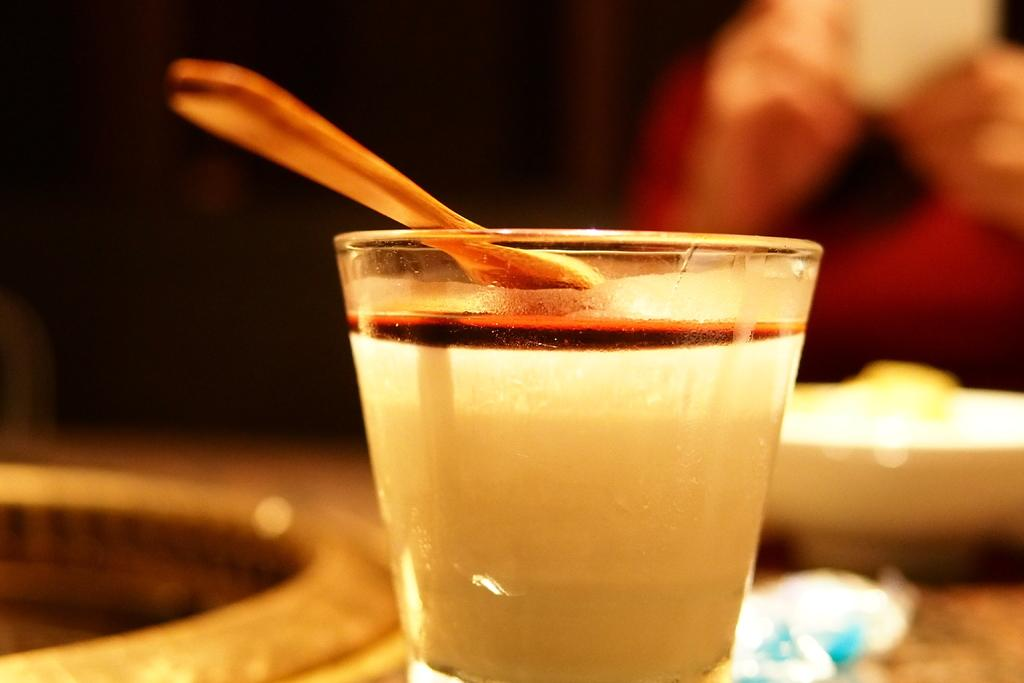What piece of furniture is present in the image? There is a table in the image. What object is placed on the table? There is a glass on the table. What is inside the glass? There is liquid in the glass. What utensil is in the glass? There is a spoon in the glass. Can you describe the background of the image? The background of the image is blurry. What type of club can be seen in the image? There is no club present in the image. Is there a monkey sitting on the table in the image? No, there is no monkey present in the image. 